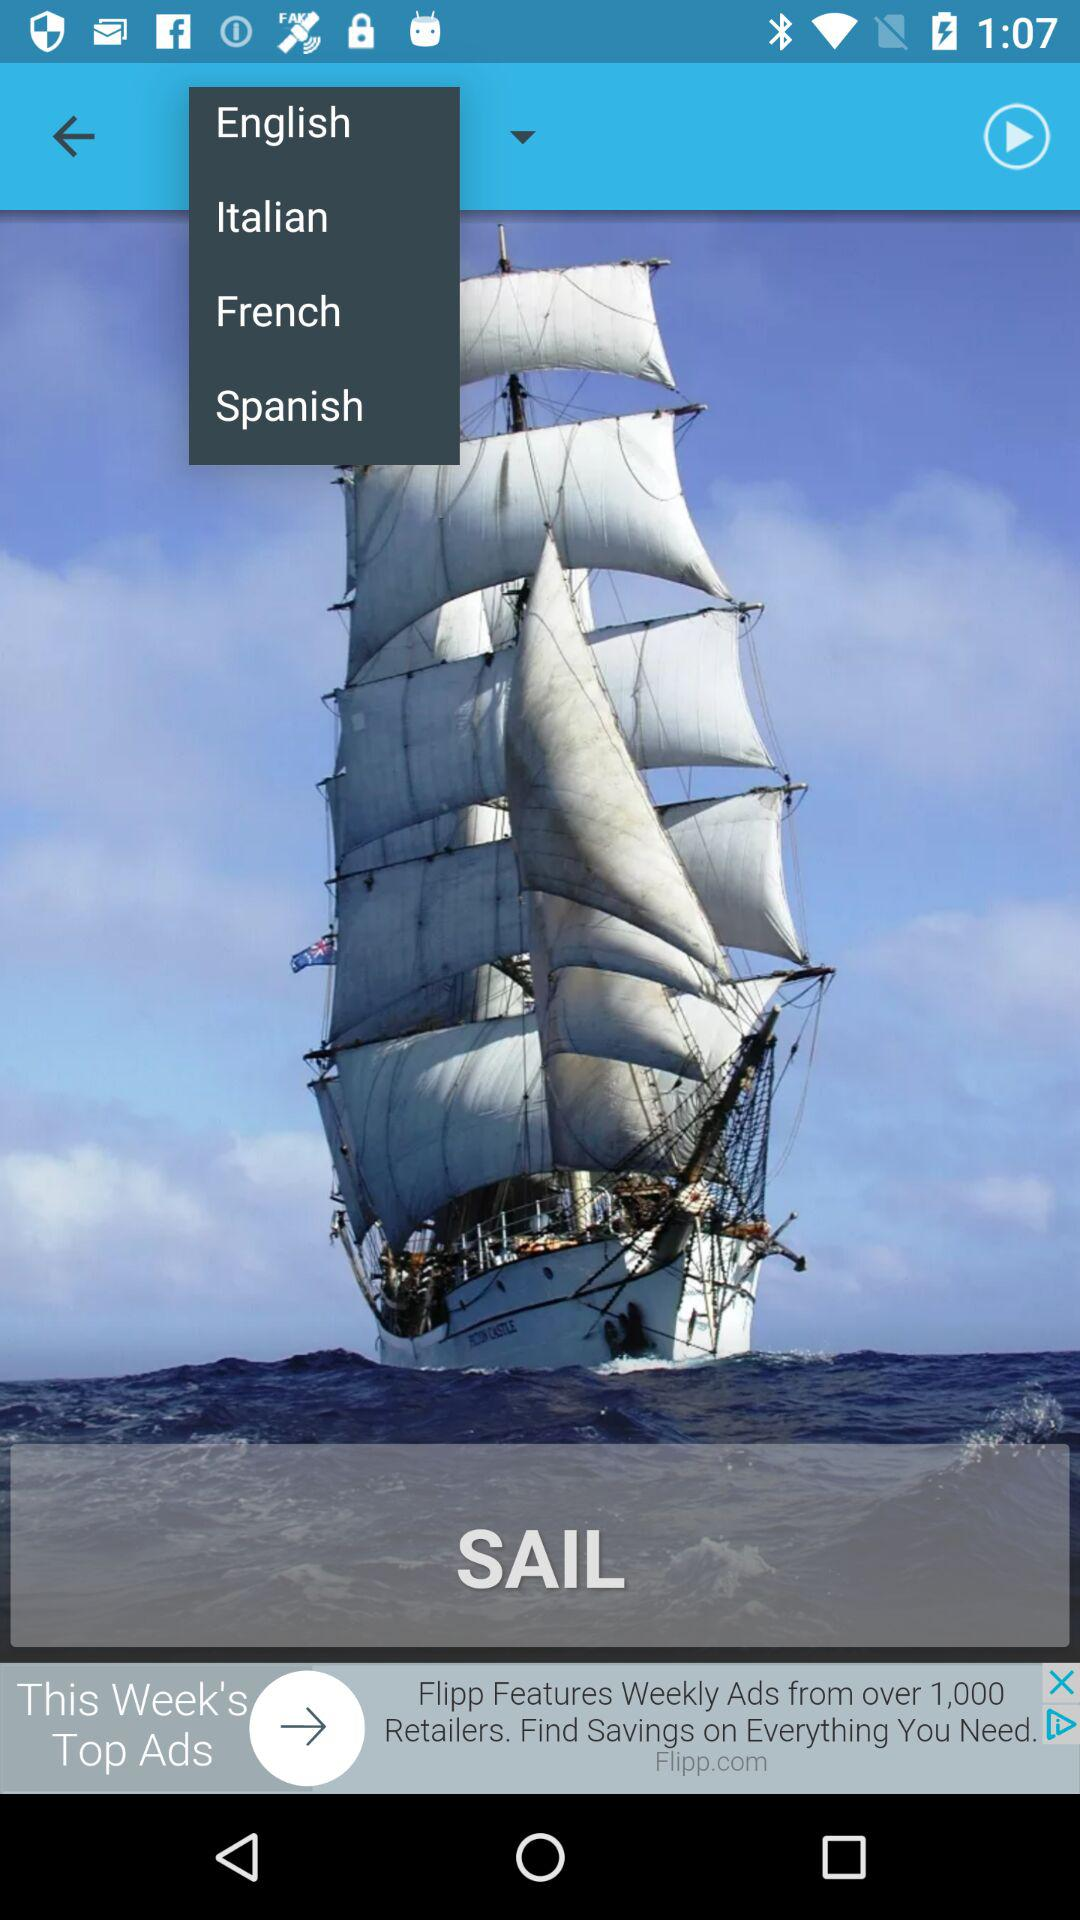How many language options are there?
Answer the question using a single word or phrase. 4 